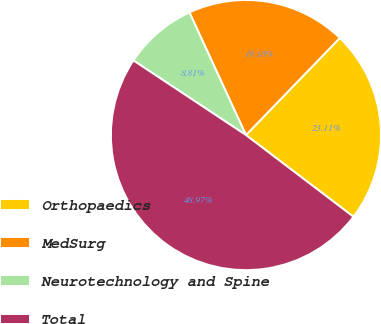Convert chart to OTSL. <chart><loc_0><loc_0><loc_500><loc_500><pie_chart><fcel>Orthopaedics<fcel>MedSurg<fcel>Neurotechnology and Spine<fcel>Total<nl><fcel>23.11%<fcel>19.1%<fcel>8.81%<fcel>48.97%<nl></chart> 